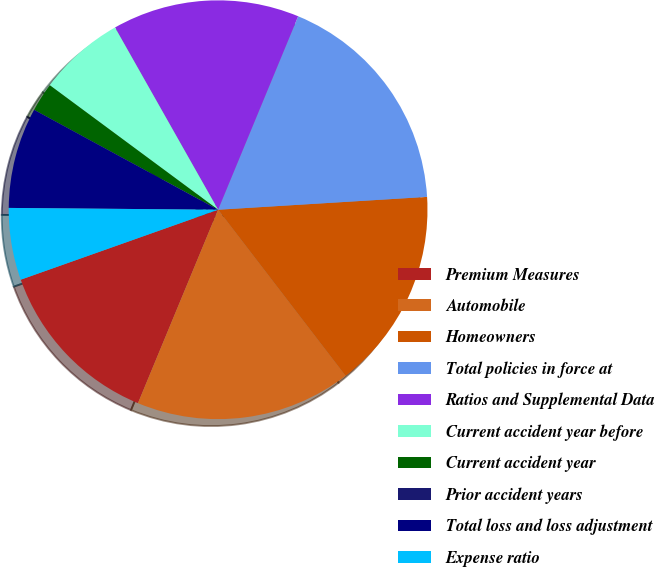Convert chart to OTSL. <chart><loc_0><loc_0><loc_500><loc_500><pie_chart><fcel>Premium Measures<fcel>Automobile<fcel>Homeowners<fcel>Total policies in force at<fcel>Ratios and Supplemental Data<fcel>Current accident year before<fcel>Current accident year<fcel>Prior accident years<fcel>Total loss and loss adjustment<fcel>Expense ratio<nl><fcel>13.33%<fcel>16.67%<fcel>15.56%<fcel>17.78%<fcel>14.44%<fcel>6.67%<fcel>2.22%<fcel>0.0%<fcel>7.78%<fcel>5.56%<nl></chart> 